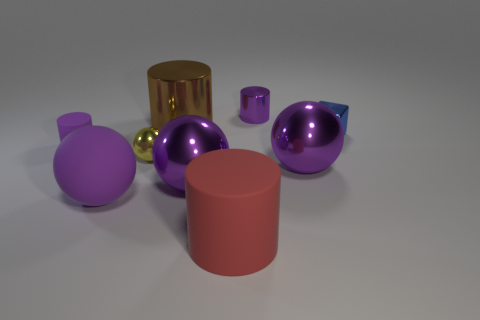How does the lighting in this scene affect the appearance of these objects? The lighting in the scene casts soft shadows and highlights on the objects, enhancing their three-dimensional form. It appears to come from above, possibly from a slight angle, as the shadows are relatively short and positioned slightly to the side of each object. Could you imagine a real-world use for these objects based on their appearance? Based on their appearance, the objects could be decorative or functional. The cylinders might serve as stylish containers or holders, while the spheres could be part of a modern art installation or serve as ornamental items in a contemporary space. 